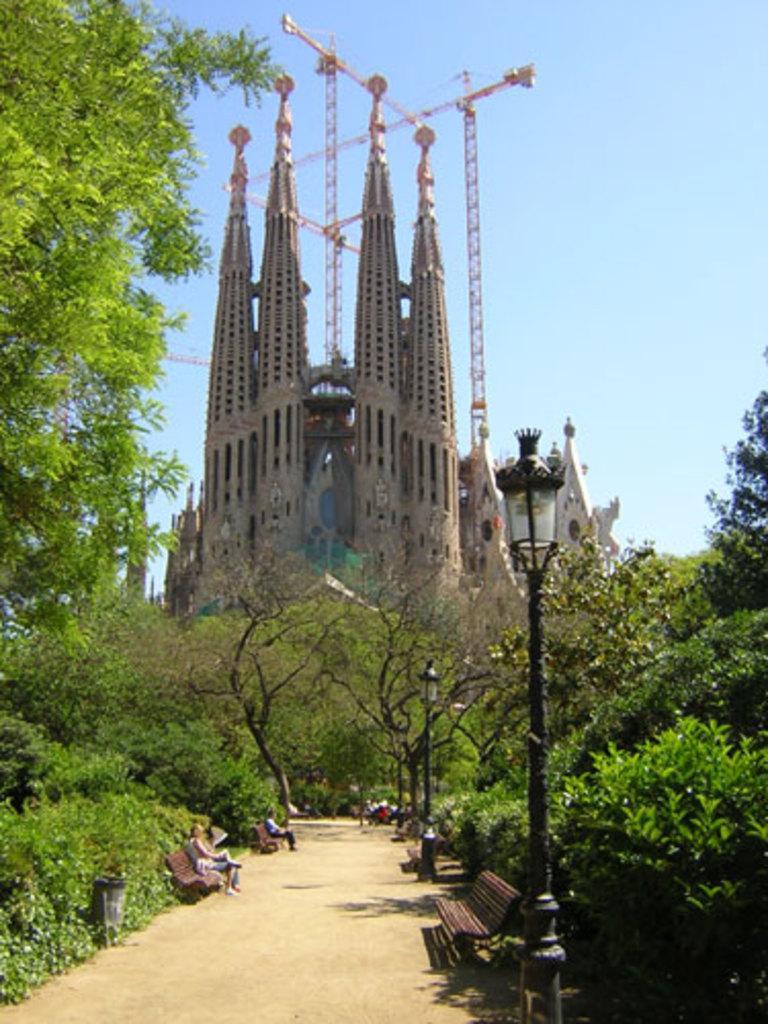Describe this image in one or two sentences. In this picture we can see benches with some people sitting on it, poles, trees, buildings and in the background we can see the sky. 